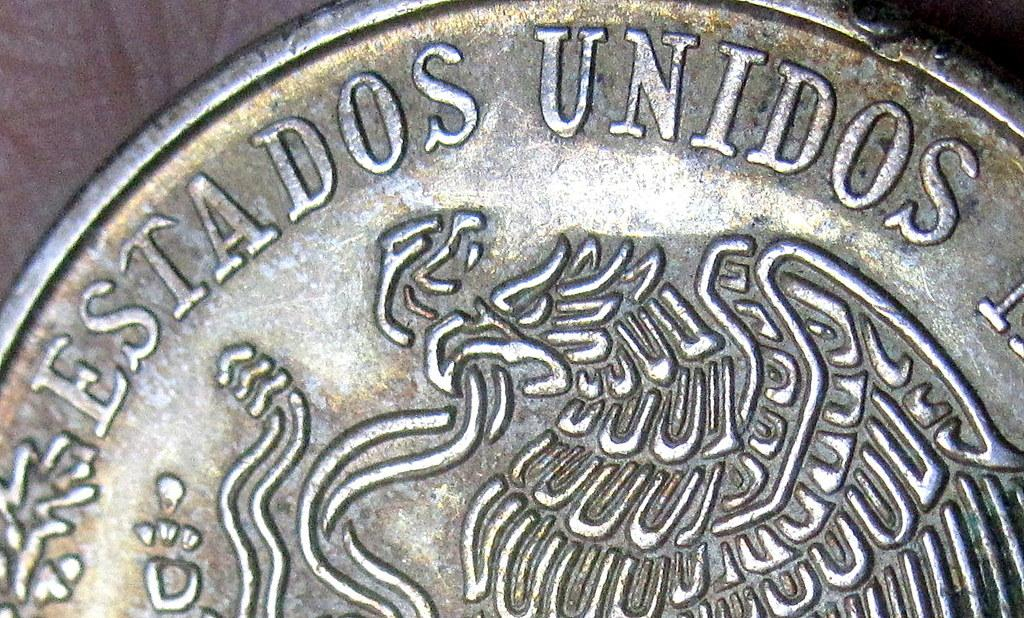<image>
Create a compact narrative representing the image presented. The close up of this silver coin and it says Estados. 